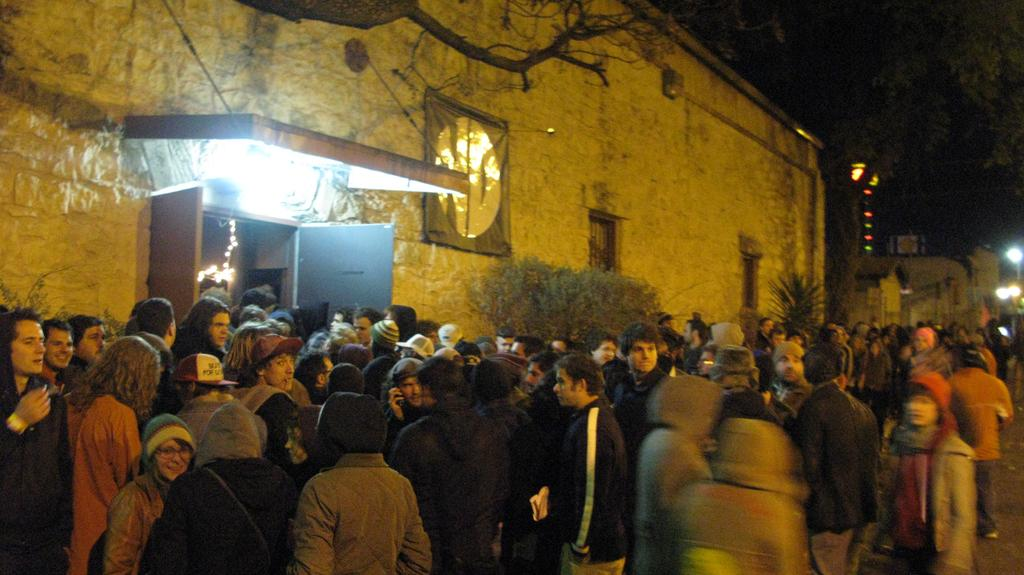What is the main subject of the image? The main subject of the image is a group of people standing in the center. Can you describe the appearance of some people in the group? Some people in the group are wearing hats. What can be seen in the background of the image? There is a building, a wall, a door, lights, windows, and trees in the background of the image. What type of glass is being used for the business meeting in the image? There is no glass or business meeting present in the image; it features a group of people standing in the center with a background containing a building, a wall, a door, lights, windows, and trees. Is there a tent visible in the image? No, there is no tent present in the image. 